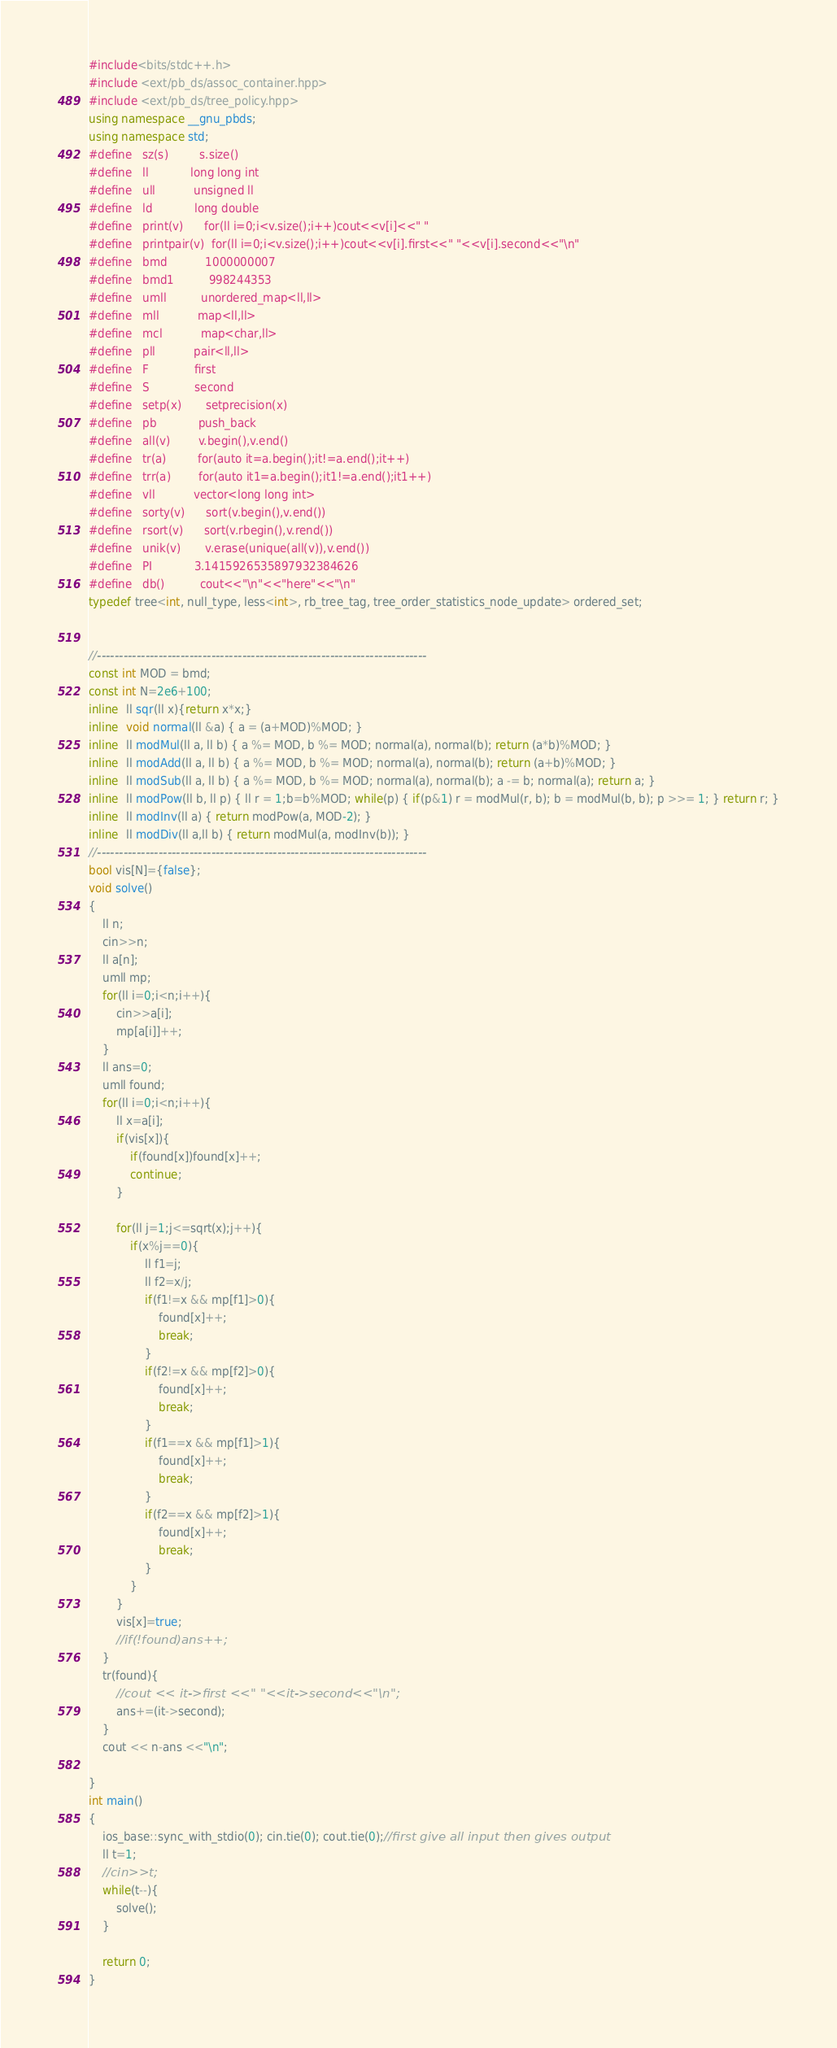Convert code to text. <code><loc_0><loc_0><loc_500><loc_500><_C++_>#include<bits/stdc++.h>
#include <ext/pb_ds/assoc_container.hpp>
#include <ext/pb_ds/tree_policy.hpp>
using namespace __gnu_pbds;
using namespace std;
#define   sz(s)         s.size()
#define   ll            long long int
#define   ull           unsigned ll
#define   ld            long double
#define   print(v)      for(ll i=0;i<v.size();i++)cout<<v[i]<<" "
#define   printpair(v)  for(ll i=0;i<v.size();i++)cout<<v[i].first<<" "<<v[i].second<<"\n"
#define   bmd           1000000007
#define   bmd1          998244353
#define   umll          unordered_map<ll,ll>
#define   mll           map<ll,ll>
#define   mcl           map<char,ll>
#define   pll           pair<ll,ll>
#define   F             first
#define   S             second
#define   setp(x)       setprecision(x)
#define   pb            push_back
#define   all(v)        v.begin(),v.end()
#define   tr(a)         for(auto it=a.begin();it!=a.end();it++)
#define   trr(a)        for(auto it1=a.begin();it1!=a.end();it1++)
#define   vll           vector<long long int>
#define   sorty(v)      sort(v.begin(),v.end())
#define   rsort(v)      sort(v.rbegin(),v.rend())
#define   unik(v)       v.erase(unique(all(v)),v.end())
#define   PI            3.1415926535897932384626
#define   db()          cout<<"\n"<<"here"<<"\n"
typedef tree<int, null_type, less<int>, rb_tree_tag, tree_order_statistics_node_update> ordered_set;


//---------------------------------------------------------------------------
const int MOD = bmd;
const int N=2e6+100;
inline  ll sqr(ll x){return x*x;}
inline  void normal(ll &a) { a = (a+MOD)%MOD; }
inline  ll modMul(ll a, ll b) { a %= MOD, b %= MOD; normal(a), normal(b); return (a*b)%MOD; }
inline  ll modAdd(ll a, ll b) { a %= MOD, b %= MOD; normal(a), normal(b); return (a+b)%MOD; }
inline  ll modSub(ll a, ll b) { a %= MOD, b %= MOD; normal(a), normal(b); a -= b; normal(a); return a; }
inline  ll modPow(ll b, ll p) { ll r = 1;b=b%MOD; while(p) { if(p&1) r = modMul(r, b); b = modMul(b, b); p >>= 1; } return r; }
inline  ll modInv(ll a) { return modPow(a, MOD-2); }
inline  ll modDiv(ll a,ll b) { return modMul(a, modInv(b)); }
//---------------------------------------------------------------------------
bool vis[N]={false};
void solve()
{
    ll n;
    cin>>n;
    ll a[n];
    umll mp;
    for(ll i=0;i<n;i++){
        cin>>a[i];
        mp[a[i]]++;
    }
    ll ans=0;
    umll found;
    for(ll i=0;i<n;i++){
        ll x=a[i];
        if(vis[x]){
            if(found[x])found[x]++;
            continue;
        }

        for(ll j=1;j<=sqrt(x);j++){
            if(x%j==0){
                ll f1=j;
                ll f2=x/j;
                if(f1!=x && mp[f1]>0){
                    found[x]++;
                    break;
                }
                if(f2!=x && mp[f2]>0){
                    found[x]++;
                    break;
                }
                if(f1==x && mp[f1]>1){
                    found[x]++;
                    break;
                }
                if(f2==x && mp[f2]>1){
                    found[x]++;
                    break;
                }
            }
        }
        vis[x]=true;
        //if(!found)ans++;
    }
    tr(found){
        //cout << it->first <<" "<<it->second<<"\n";
        ans+=(it->second);
    }
    cout << n-ans <<"\n";

}
int main()
{
    ios_base::sync_with_stdio(0); cin.tie(0); cout.tie(0);//first give all input then gives output
    ll t=1;
    //cin>>t;
    while(t--){
        solve();
    }

    return 0;
}
</code> 